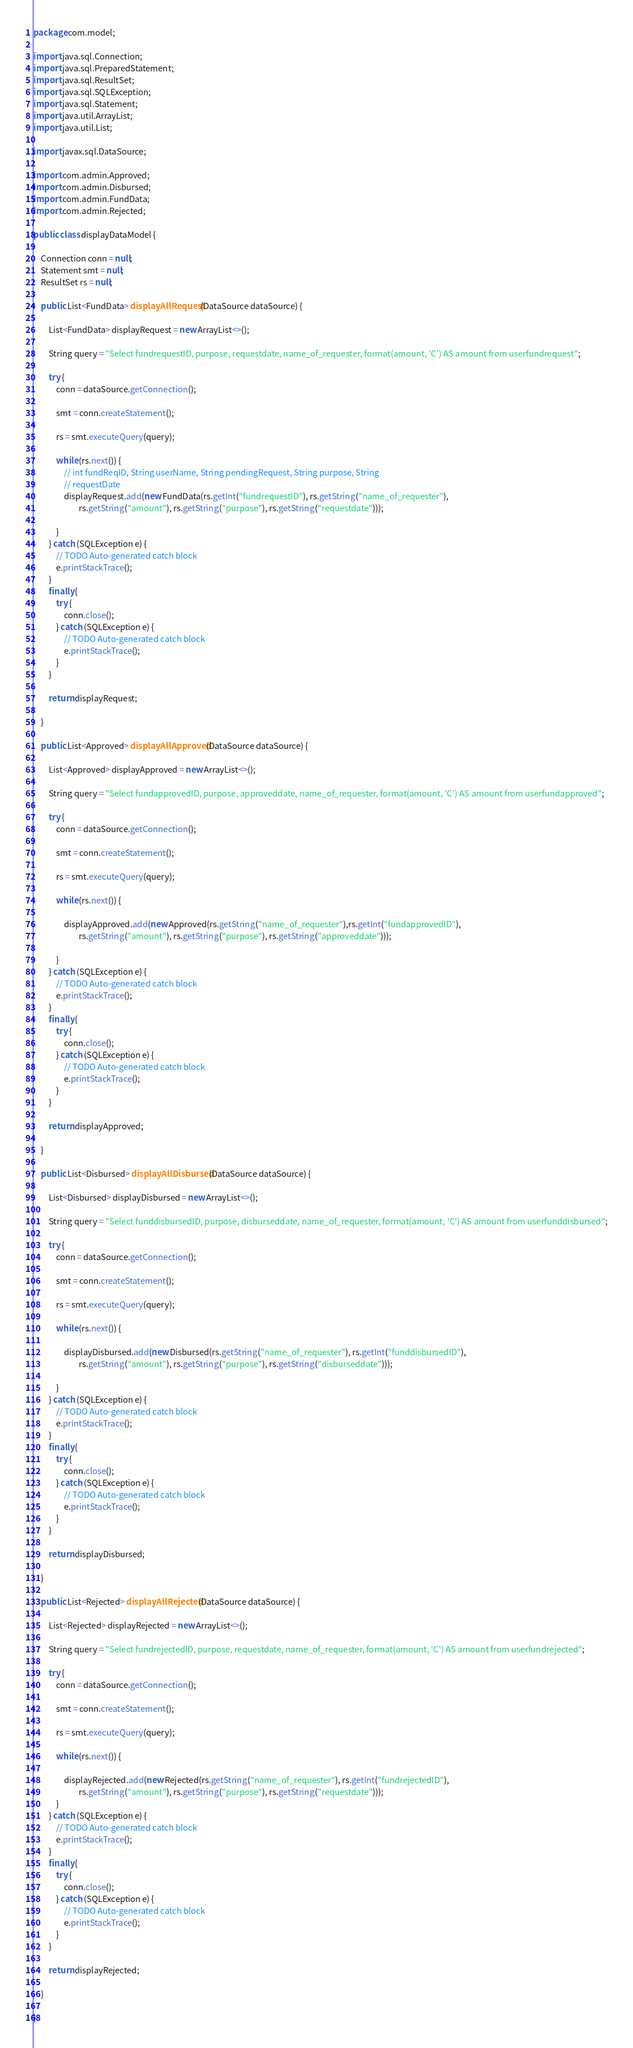Convert code to text. <code><loc_0><loc_0><loc_500><loc_500><_Java_>package com.model;

import java.sql.Connection;
import java.sql.PreparedStatement;
import java.sql.ResultSet;
import java.sql.SQLException;
import java.sql.Statement;
import java.util.ArrayList;
import java.util.List;

import javax.sql.DataSource;

import com.admin.Approved;
import com.admin.Disbursed;
import com.admin.FundData;
import com.admin.Rejected;

public class displayDataModel {

	Connection conn = null;
	Statement smt = null;
	ResultSet rs = null;

	public List<FundData> displayAllRequest(DataSource dataSource) {

		List<FundData> displayRequest = new ArrayList<>();

		String query = "Select fundrequestID, purpose, requestdate, name_of_requester, format(amount, 'C') AS amount from userfundrequest";

		try {
			conn = dataSource.getConnection();

			smt = conn.createStatement();

			rs = smt.executeQuery(query);

			while (rs.next()) {
				// int fundReqID, String userName, String pendingRequest, String purpose, String
				// requestDate
				displayRequest.add(new FundData(rs.getInt("fundrequestID"), rs.getString("name_of_requester"),
						rs.getString("amount"), rs.getString("purpose"), rs.getString("requestdate")));

			}
		} catch (SQLException e) {
			// TODO Auto-generated catch block
			e.printStackTrace();
		}
		finally {
			try {
				conn.close();
			} catch (SQLException e) {
				// TODO Auto-generated catch block
				e.printStackTrace();
			}
		}

		return displayRequest;

	}

	public List<Approved> displayAllApproved(DataSource dataSource) {

		List<Approved> displayApproved = new ArrayList<>();

		String query = "Select fundapprovedID, purpose, approveddate, name_of_requester, format(amount, 'C') AS amount from userfundapproved";

		try {
			conn = dataSource.getConnection();

			smt = conn.createStatement();

			rs = smt.executeQuery(query);

			while (rs.next()) {

				displayApproved.add(new Approved(rs.getString("name_of_requester"),rs.getInt("fundapprovedID"),
						rs.getString("amount"), rs.getString("purpose"), rs.getString("approveddate")));

			}
		} catch (SQLException e) {
			// TODO Auto-generated catch block
			e.printStackTrace();
		}
		finally {
			try {
				conn.close();
			} catch (SQLException e) {
				// TODO Auto-generated catch block
				e.printStackTrace();
			}
		}

		return displayApproved;

	}

	public List<Disbursed> displayAllDisbursed(DataSource dataSource) {

		List<Disbursed> displayDisbursed = new ArrayList<>();

		String query = "Select funddisbursedID, purpose, disburseddate, name_of_requester, format(amount, 'C') AS amount from userfunddisbursed";

		try {
			conn = dataSource.getConnection();

			smt = conn.createStatement();

			rs = smt.executeQuery(query);

			while (rs.next()) {

				displayDisbursed.add(new Disbursed(rs.getString("name_of_requester"), rs.getInt("funddisbursedID"),
						rs.getString("amount"), rs.getString("purpose"), rs.getString("disburseddate")));

			}
		} catch (SQLException e) {
			// TODO Auto-generated catch block
			e.printStackTrace();
		}
		finally {
			try {
				conn.close();
			} catch (SQLException e) {
				// TODO Auto-generated catch block
				e.printStackTrace();
			}
		}

		return displayDisbursed;

	}

	public List<Rejected> displayAllRejected(DataSource dataSource) {

		List<Rejected> displayRejected = new ArrayList<>();

		String query = "Select fundrejectedID, purpose, requestdate, name_of_requester, format(amount, 'C') AS amount from userfundrejected";

		try {
			conn = dataSource.getConnection();

			smt = conn.createStatement();

			rs = smt.executeQuery(query);

			while (rs.next()) {

				displayRejected.add(new Rejected(rs.getString("name_of_requester"), rs.getInt("fundrejectedID"),
						rs.getString("amount"), rs.getString("purpose"), rs.getString("requestdate")));
			}
		} catch (SQLException e) {
			// TODO Auto-generated catch block
			e.printStackTrace();
		}
		finally {
			try {
				conn.close();
			} catch (SQLException e) {
				// TODO Auto-generated catch block
				e.printStackTrace();
			}
		}

		return displayRejected;

	}

}
</code> 